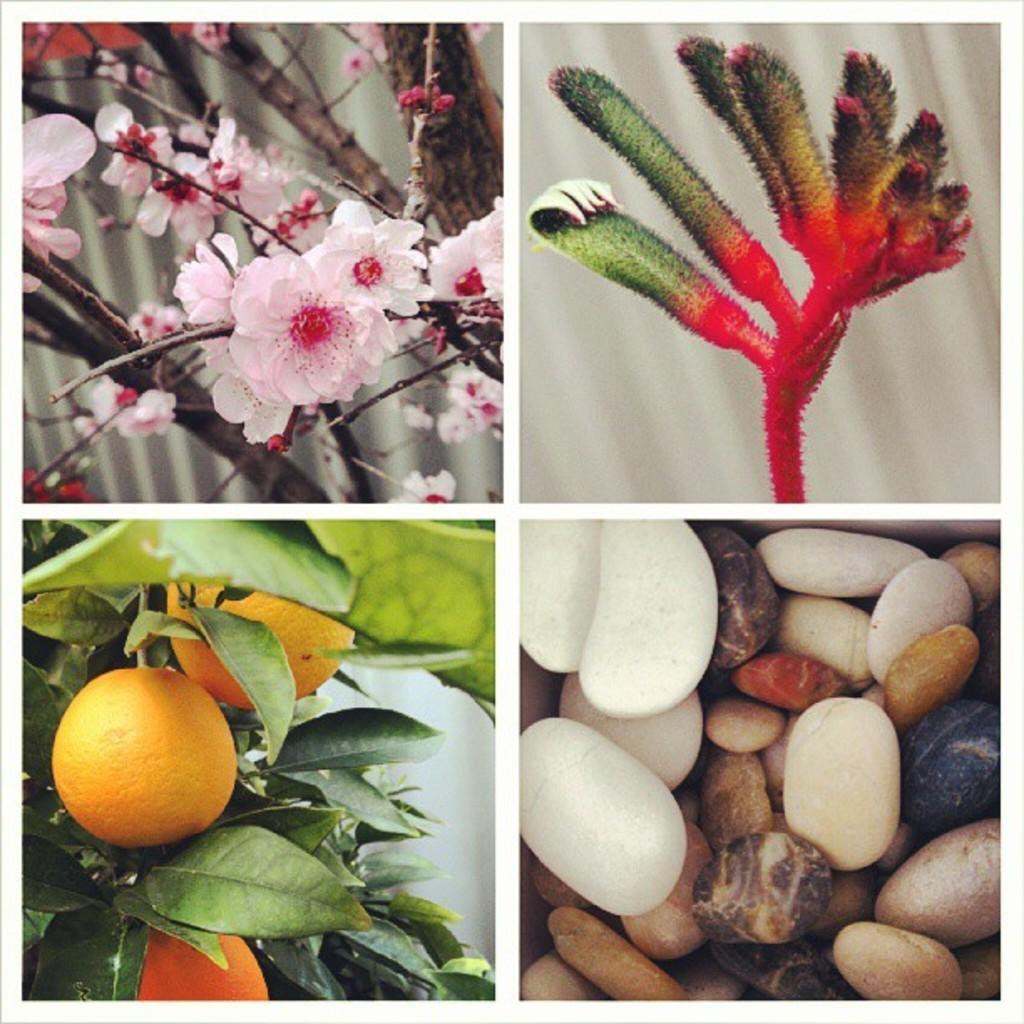Can you describe this image briefly? This picture having four college frames. On the top right there is a leaf. On the top left we can see flowers and plant. On the bottom left we can see of oranges in a plant. On the bottom right we can see different color stones. 